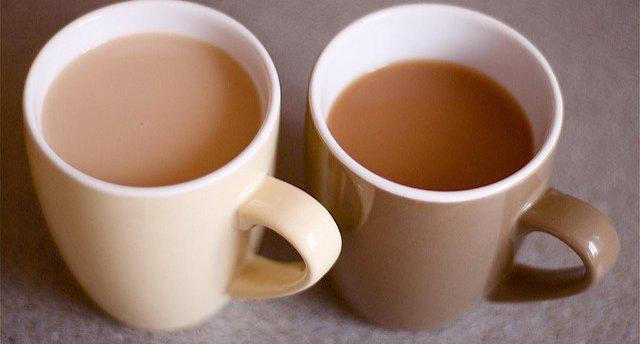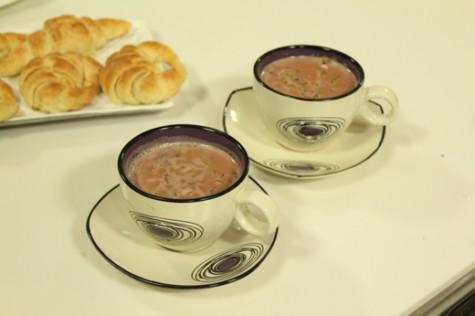The first image is the image on the left, the second image is the image on the right. Evaluate the accuracy of this statement regarding the images: "There is at least one spoon placed in a saucer.". Is it true? Answer yes or no. No. The first image is the image on the left, the second image is the image on the right. Examine the images to the left and right. Is the description "Cups in the right image are on saucers, and cups in the left image are not." accurate? Answer yes or no. Yes. 